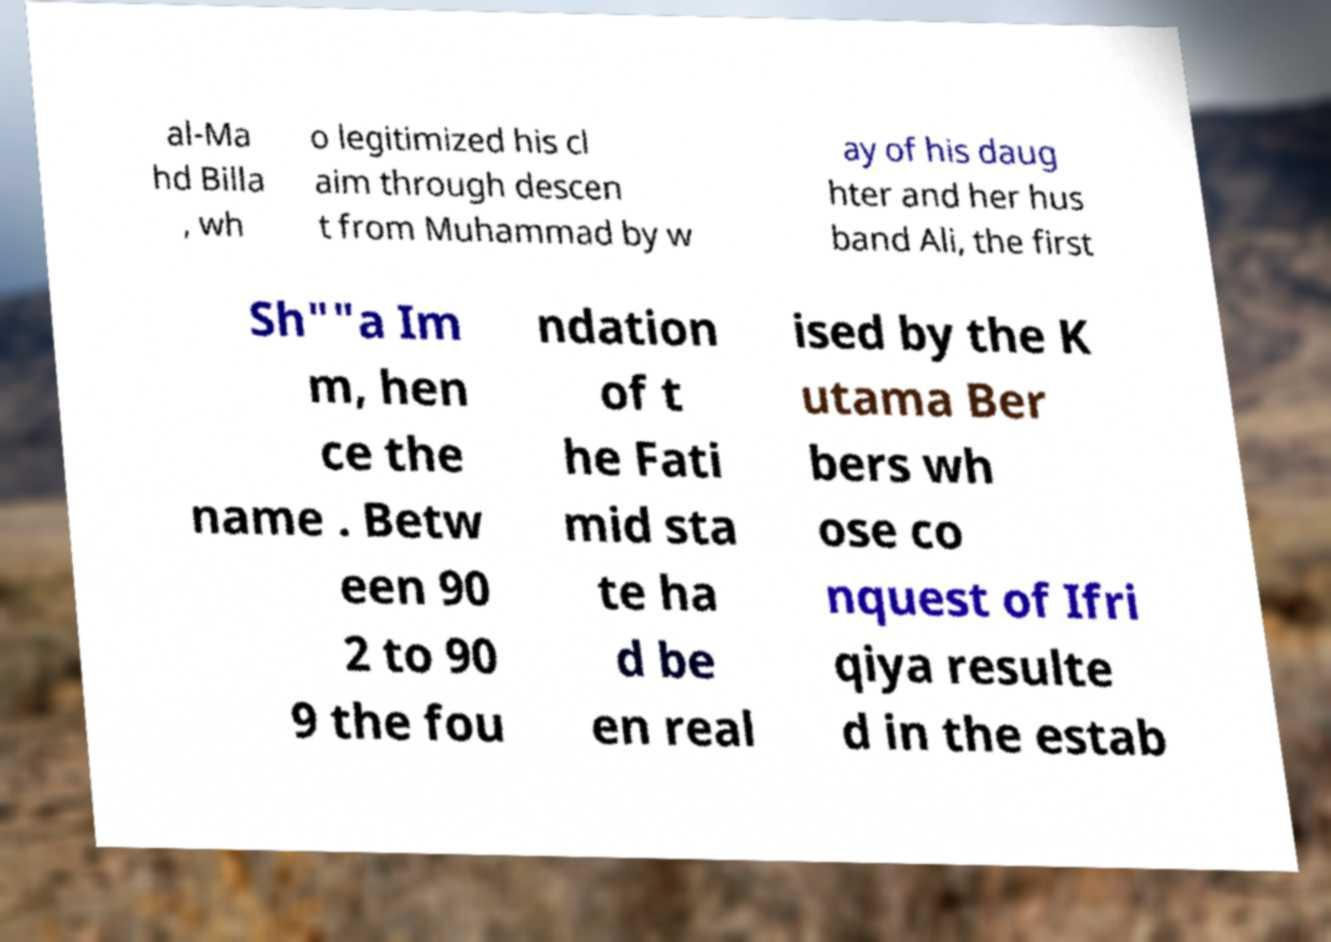Please identify and transcribe the text found in this image. al-Ma hd Billa , wh o legitimized his cl aim through descen t from Muhammad by w ay of his daug hter and her hus band Ali, the first Sh""a Im m, hen ce the name . Betw een 90 2 to 90 9 the fou ndation of t he Fati mid sta te ha d be en real ised by the K utama Ber bers wh ose co nquest of Ifri qiya resulte d in the estab 